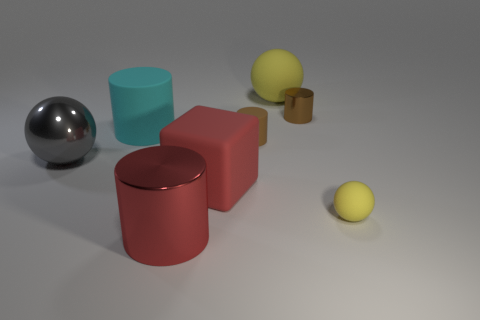Do the small yellow ball and the yellow thing that is left of the small matte sphere have the same material?
Offer a very short reply. Yes. Is there anything else that is the same color as the large matte cube?
Offer a terse response. Yes. What number of things are cylinders that are on the left side of the big red rubber cube or gray metallic spheres that are left of the big metallic cylinder?
Your answer should be compact. 3. What is the shape of the rubber object that is both in front of the gray thing and to the left of the tiny rubber cylinder?
Provide a succinct answer. Cube. There is a large metallic thing on the left side of the red shiny thing; what number of big red metallic cylinders are behind it?
Your answer should be very brief. 0. Is there anything else that is made of the same material as the red block?
Offer a very short reply. Yes. How many objects are either things in front of the cyan cylinder or matte balls?
Give a very brief answer. 6. How big is the yellow matte object in front of the tiny shiny cylinder?
Your answer should be very brief. Small. What is the material of the cyan object?
Provide a short and direct response. Rubber. The small brown object that is on the left side of the metallic cylinder that is behind the gray object is what shape?
Make the answer very short. Cylinder. 